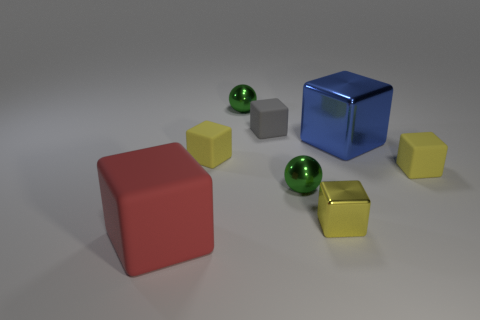How many big objects are either gray rubber things or brown cylinders?
Your answer should be very brief. 0. Are there any small yellow blocks that are left of the big cube to the right of the large red rubber cube that is left of the gray matte thing?
Your answer should be very brief. Yes. Is there a cyan sphere of the same size as the red matte block?
Ensure brevity in your answer.  No. What material is the gray thing that is the same size as the yellow shiny block?
Provide a short and direct response. Rubber. Does the blue metallic object have the same size as the metallic cube that is to the left of the blue shiny thing?
Your answer should be compact. No. How many rubber objects are either small green spheres or red blocks?
Your answer should be very brief. 1. How many yellow rubber objects are the same shape as the tiny yellow shiny thing?
Provide a succinct answer. 2. Do the green shiny ball behind the blue thing and the red cube that is to the left of the blue metal object have the same size?
Offer a very short reply. No. What is the shape of the green metal thing in front of the gray object?
Your response must be concise. Sphere. There is a gray object that is the same shape as the big red matte thing; what material is it?
Ensure brevity in your answer.  Rubber. 